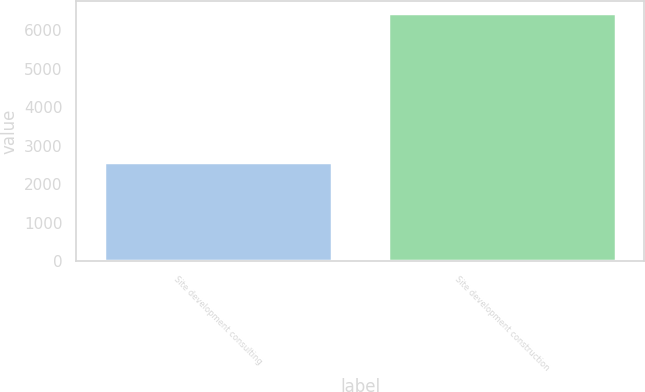<chart> <loc_0><loc_0><loc_500><loc_500><bar_chart><fcel>Site development consulting<fcel>Site development construction<nl><fcel>2578<fcel>6431<nl></chart> 